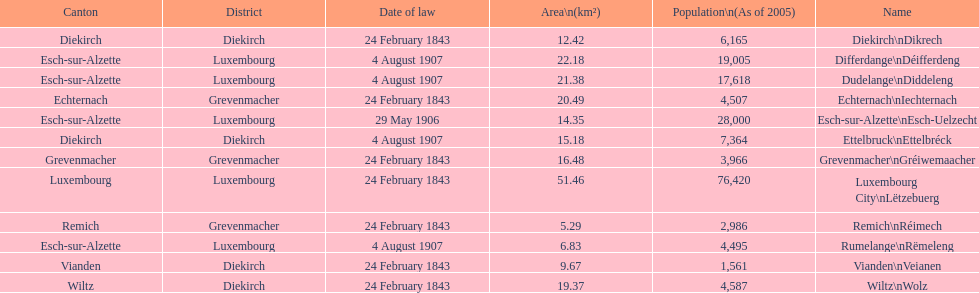Which canton falls under the date of law of 24 february 1843 and has a population of 3,966? Grevenmacher. Would you be able to parse every entry in this table? {'header': ['Canton', 'District', 'Date of law', 'Area\\n(km²)', 'Population\\n(As of 2005)', 'Name'], 'rows': [['Diekirch', 'Diekirch', '24 February 1843', '12.42', '6,165', 'Diekirch\\nDikrech'], ['Esch-sur-Alzette', 'Luxembourg', '4 August 1907', '22.18', '19,005', 'Differdange\\nDéifferdeng'], ['Esch-sur-Alzette', 'Luxembourg', '4 August 1907', '21.38', '17,618', 'Dudelange\\nDiddeleng'], ['Echternach', 'Grevenmacher', '24 February 1843', '20.49', '4,507', 'Echternach\\nIechternach'], ['Esch-sur-Alzette', 'Luxembourg', '29 May 1906', '14.35', '28,000', 'Esch-sur-Alzette\\nEsch-Uelzecht'], ['Diekirch', 'Diekirch', '4 August 1907', '15.18', '7,364', 'Ettelbruck\\nEttelbréck'], ['Grevenmacher', 'Grevenmacher', '24 February 1843', '16.48', '3,966', 'Grevenmacher\\nGréiwemaacher'], ['Luxembourg', 'Luxembourg', '24 February 1843', '51.46', '76,420', 'Luxembourg City\\nLëtzebuerg'], ['Remich', 'Grevenmacher', '24 February 1843', '5.29', '2,986', 'Remich\\nRéimech'], ['Esch-sur-Alzette', 'Luxembourg', '4 August 1907', '6.83', '4,495', 'Rumelange\\nRëmeleng'], ['Vianden', 'Diekirch', '24 February 1843', '9.67', '1,561', 'Vianden\\nVeianen'], ['Wiltz', 'Diekirch', '24 February 1843', '19.37', '4,587', 'Wiltz\\nWolz']]} 